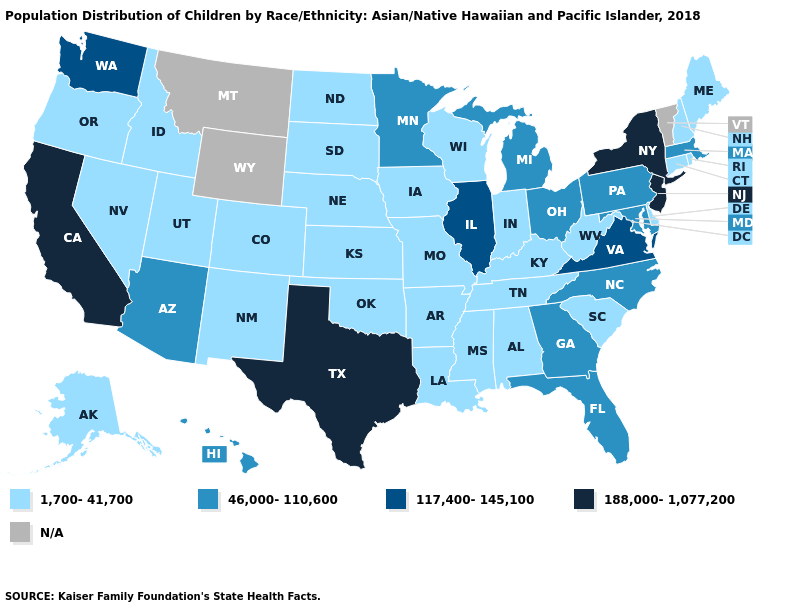Among the states that border Colorado , which have the highest value?
Keep it brief. Arizona. What is the highest value in the West ?
Answer briefly. 188,000-1,077,200. Is the legend a continuous bar?
Be succinct. No. Does Washington have the highest value in the USA?
Be succinct. No. Name the states that have a value in the range 1,700-41,700?
Write a very short answer. Alabama, Alaska, Arkansas, Colorado, Connecticut, Delaware, Idaho, Indiana, Iowa, Kansas, Kentucky, Louisiana, Maine, Mississippi, Missouri, Nebraska, Nevada, New Hampshire, New Mexico, North Dakota, Oklahoma, Oregon, Rhode Island, South Carolina, South Dakota, Tennessee, Utah, West Virginia, Wisconsin. Does Texas have the highest value in the South?
Quick response, please. Yes. What is the highest value in states that border Oklahoma?
Write a very short answer. 188,000-1,077,200. Name the states that have a value in the range 117,400-145,100?
Be succinct. Illinois, Virginia, Washington. What is the highest value in the USA?
Quick response, please. 188,000-1,077,200. Name the states that have a value in the range 46,000-110,600?
Keep it brief. Arizona, Florida, Georgia, Hawaii, Maryland, Massachusetts, Michigan, Minnesota, North Carolina, Ohio, Pennsylvania. Name the states that have a value in the range N/A?
Write a very short answer. Montana, Vermont, Wyoming. Name the states that have a value in the range 188,000-1,077,200?
Give a very brief answer. California, New Jersey, New York, Texas. What is the value of California?
Be succinct. 188,000-1,077,200. What is the value of Texas?
Be succinct. 188,000-1,077,200. Among the states that border Louisiana , which have the highest value?
Short answer required. Texas. 